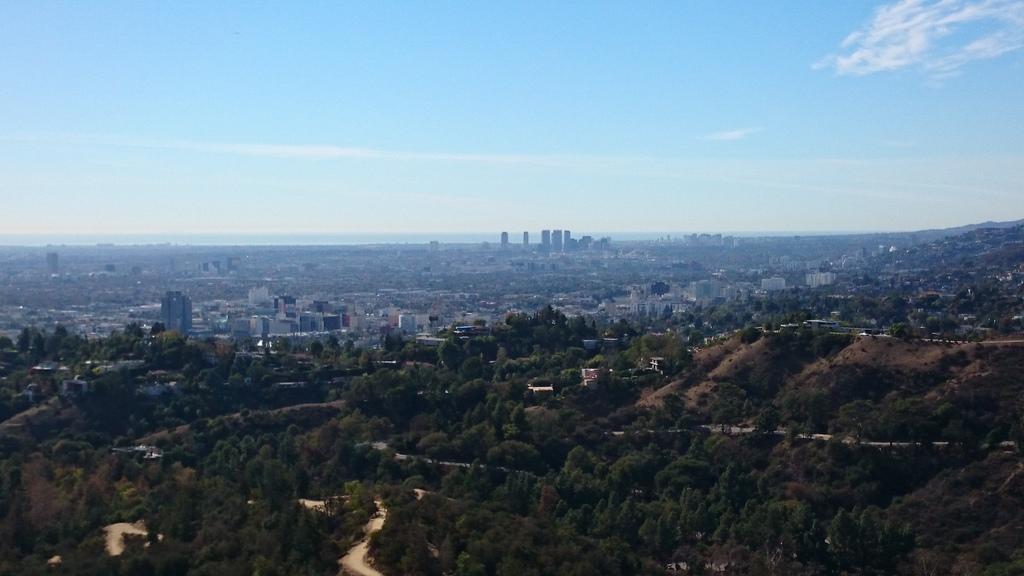Please provide a concise description of this image. This is an aerial view of an image where we can see the trees, buildings and the blue color sky with clouds in the background. 